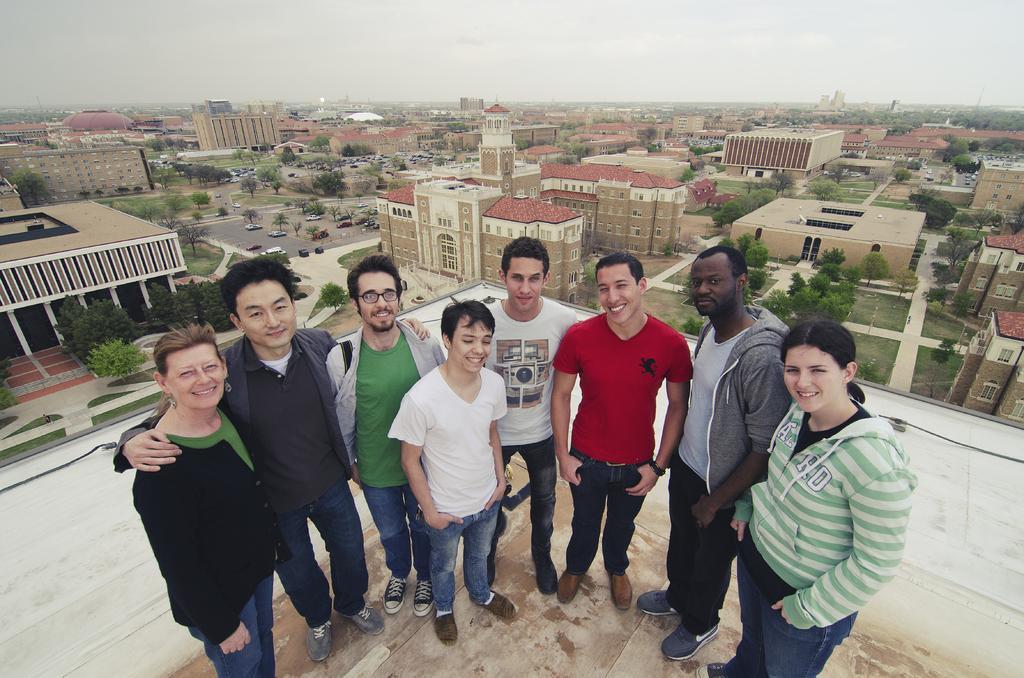Could you give a brief overview of what you see in this image? In this image, we can see some trees and buildings. There are some people in the middle of the image standing and wearing clothes. At the top of the image, we can see the sky. 